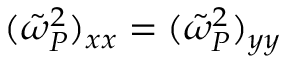Convert formula to latex. <formula><loc_0><loc_0><loc_500><loc_500>( \tilde { \omega } _ { P } ^ { 2 } ) _ { x x } = ( \tilde { \omega } _ { P } ^ { 2 } ) _ { y y }</formula> 